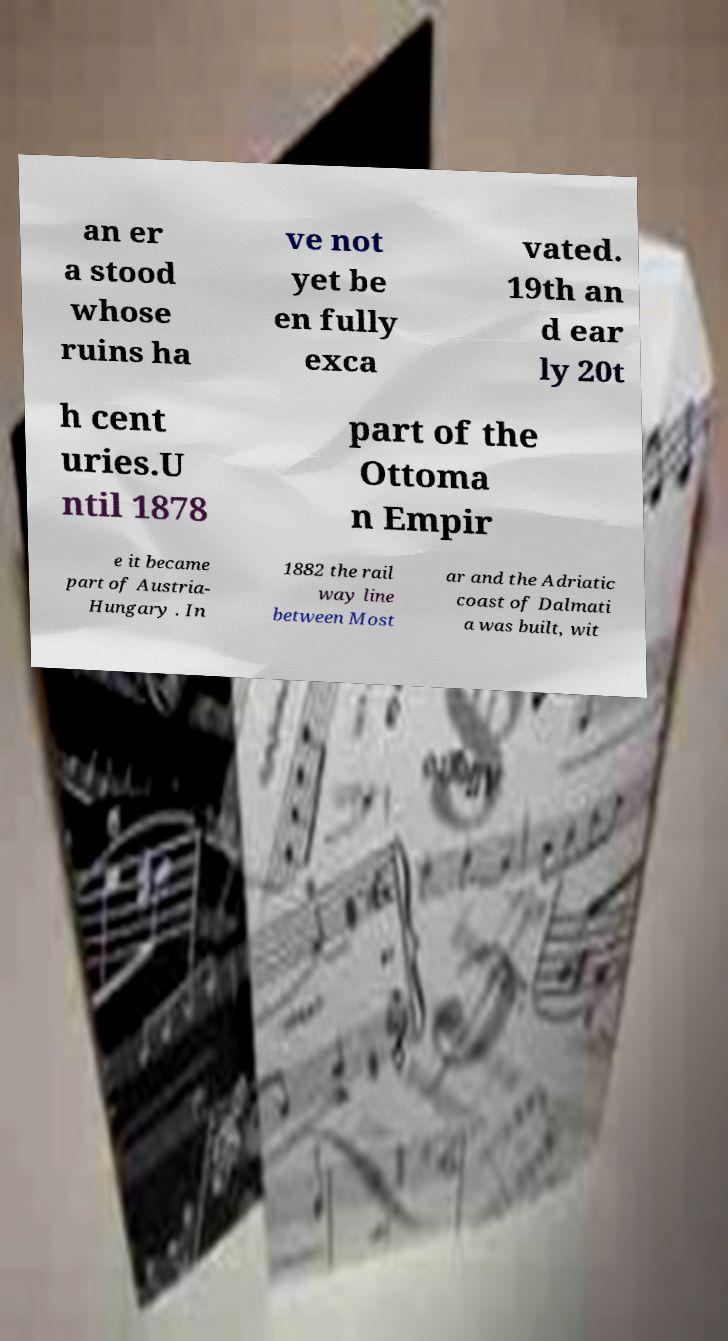Can you read and provide the text displayed in the image?This photo seems to have some interesting text. Can you extract and type it out for me? an er a stood whose ruins ha ve not yet be en fully exca vated. 19th an d ear ly 20t h cent uries.U ntil 1878 part of the Ottoma n Empir e it became part of Austria- Hungary . In 1882 the rail way line between Most ar and the Adriatic coast of Dalmati a was built, wit 